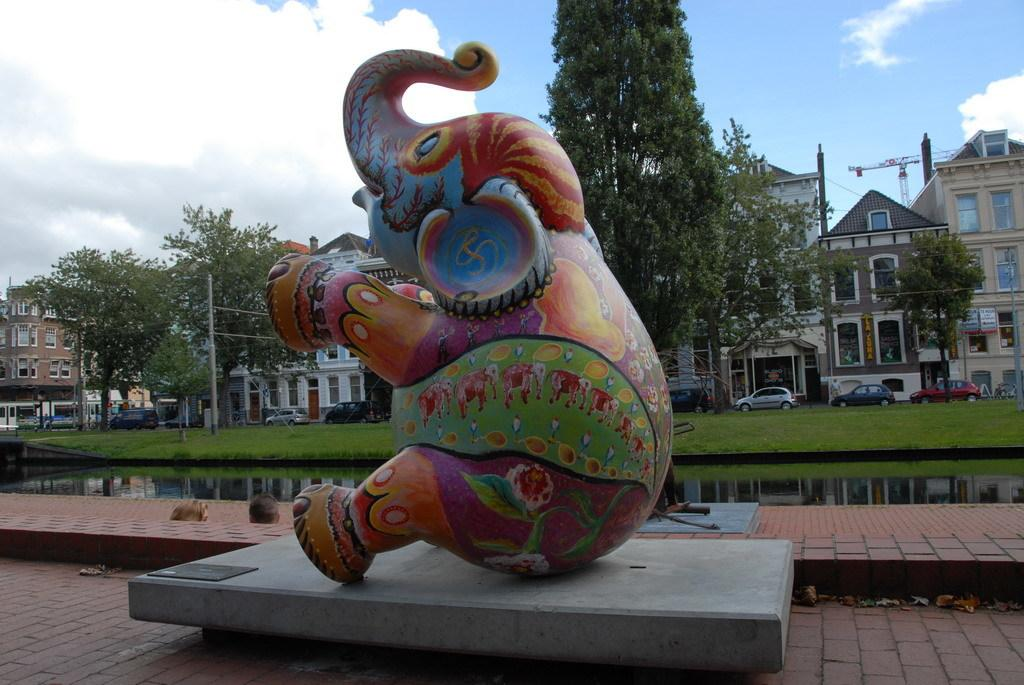What is the main subject of the statue in the image? The statue in the image is of an elephant. What can be seen in the background of the image? The sky is visible in the background of the image. What type of environment is depicted in the image? The image shows a combination of natural elements, such as water, trees, and an elephant statue, as well as man-made structures like buildings and poles. What is the primary mode of transportation in the image? Vehicles can be seen on the road in the image, indicating that cars or other vehicles are the primary mode of transportation. How many people are visible in the image? There are people in the image, but the exact number cannot be determined from the provided facts. What type of cast is visible on the elephant's leg in the image? There is no cast visible on the elephant's leg in the image, as it is a statue and not a living creature. What shape is the square that the elephant statue is standing on in the image? There is no square mentioned in the provided facts, and the image does not show the base of the statue. 